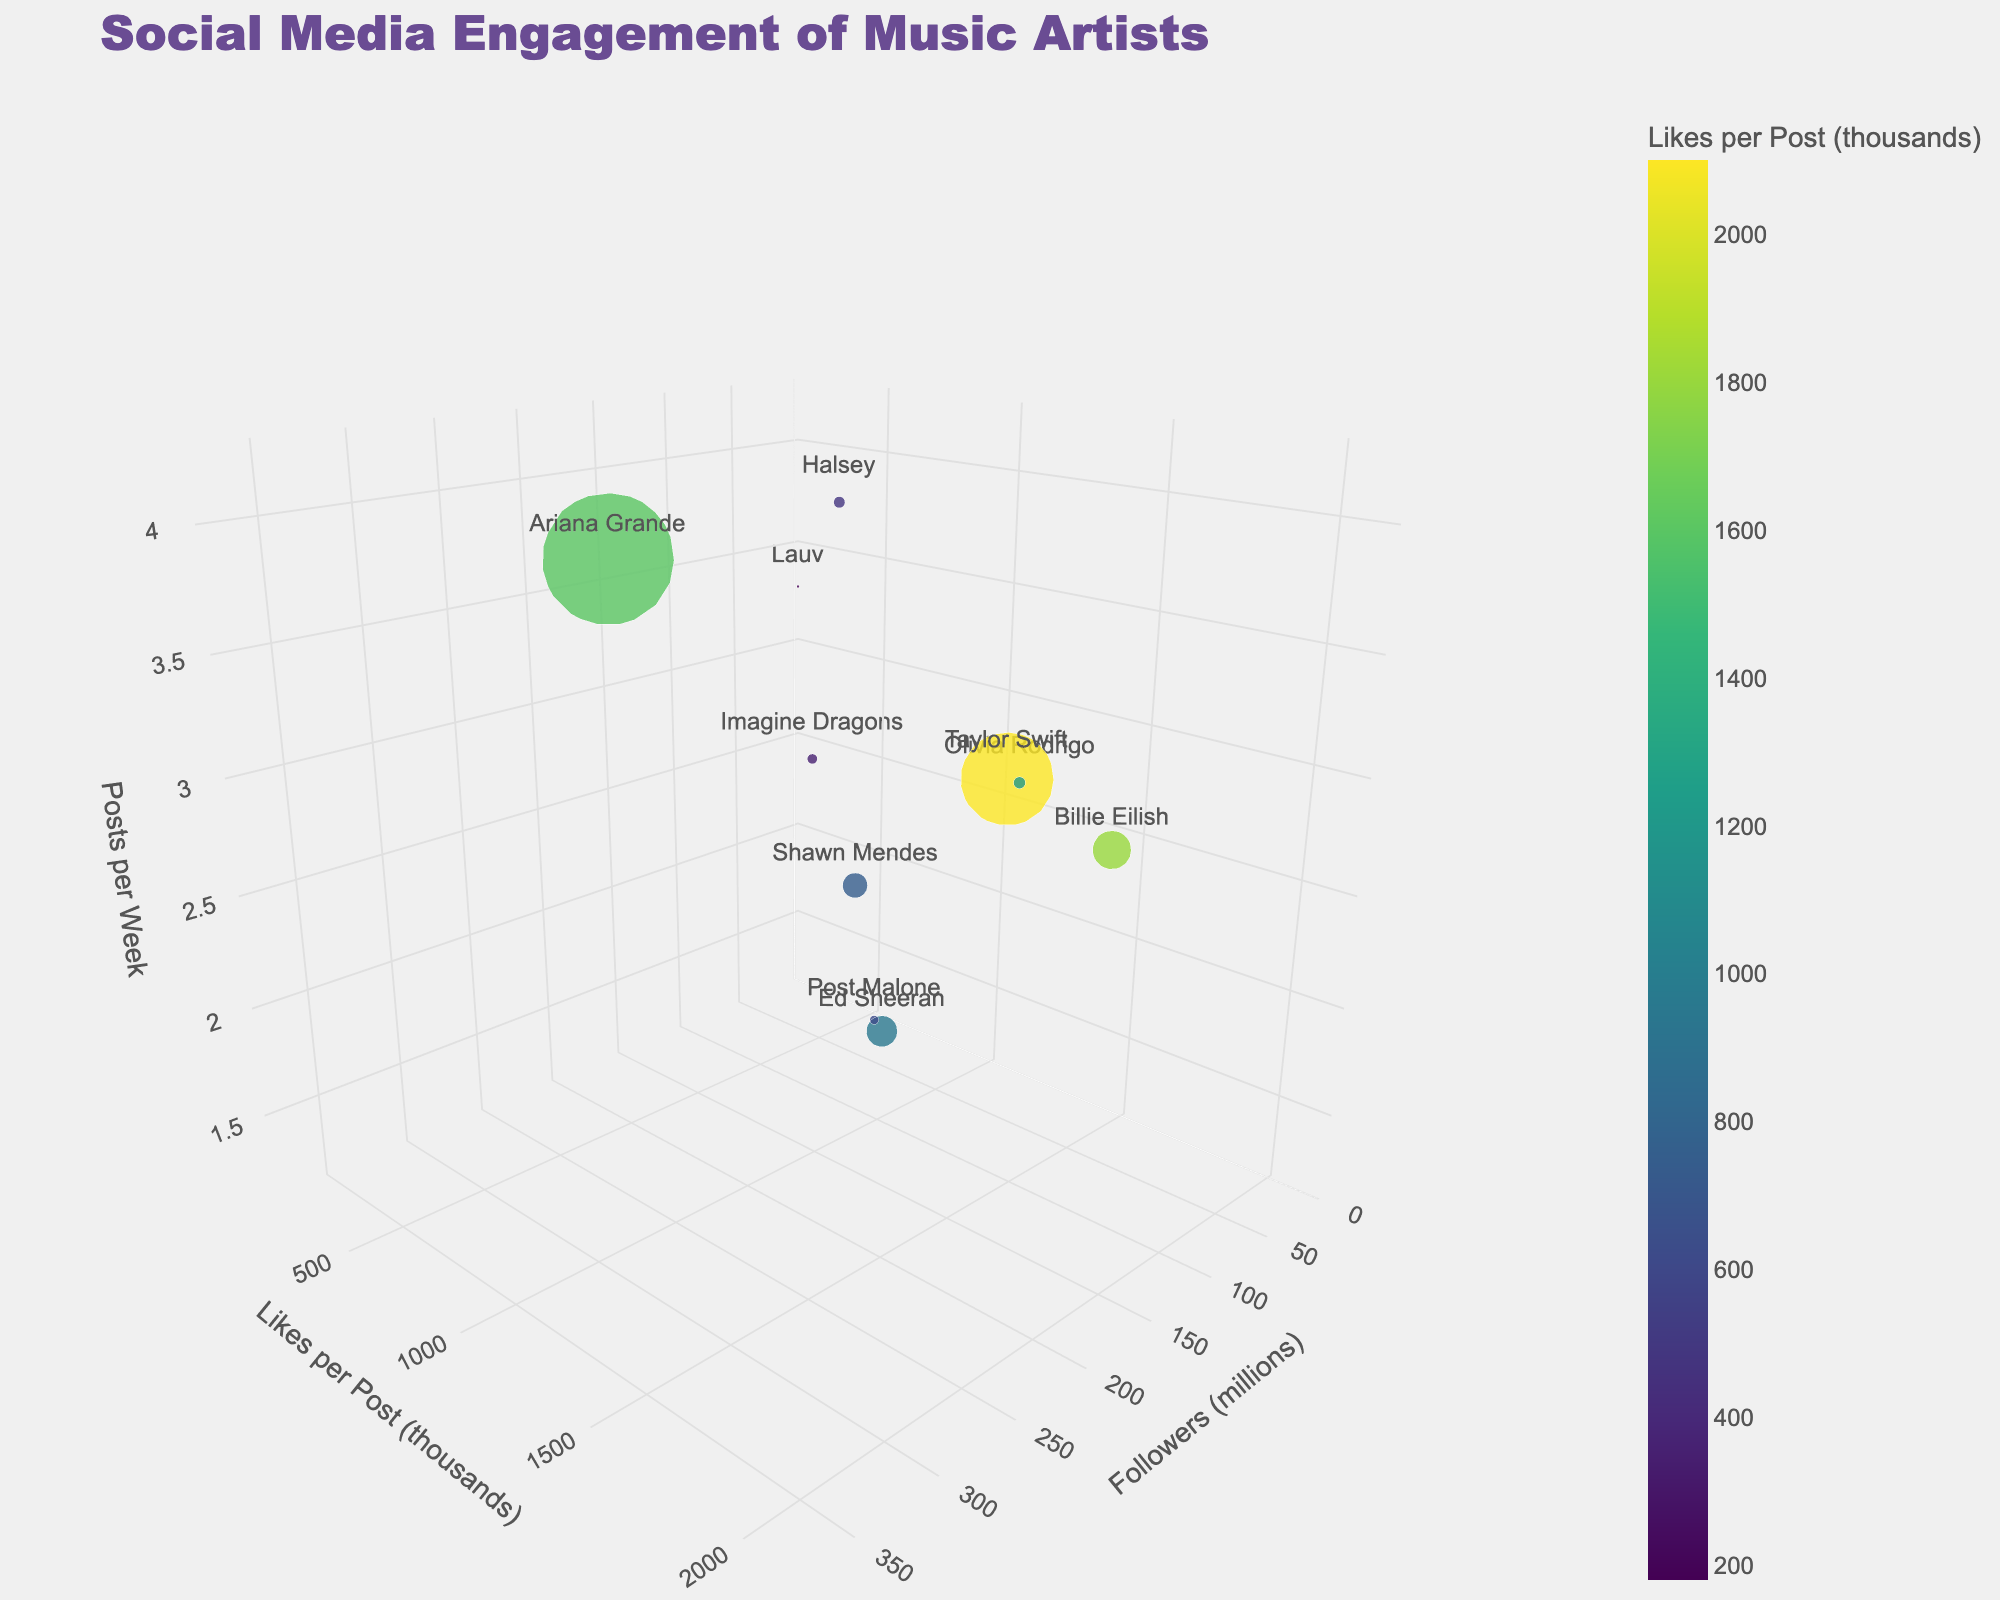Which artist has the most followers? Look for the artist with the highest value on the x-axis, which represents followers in millions. Taylor Swift has the highest value at 261 million followers.
Answer: Taylor Swift Which artist has the highest likes per post? Look for the artist with the highest value on the y-axis, which represents likes per post in thousands. Taylor Swift has the highest value at 2100 thousand likes per post.
Answer: Taylor Swift Which artist posts the most frequently per week? Look for the artist with the highest value on the z-axis, which represents posts per week. Ariana Grande posts the most frequently at 4.2 posts per week.
Answer: Ariana Grande How many artists have more than 100 million followers? Count the number of artists with a value greater than 100 million on the x-axis. Taylor Swift, Billie Eilish, and Ariana Grande each have more than 100 million followers.
Answer: 3 Who has more likes per post, Billie Eilish or Ariana Grande? Compare the y-axis values for Billie Eilish and Ariana Grande. Billie Eilish has 1800 thousand likes per post, and Ariana Grande has 1600 thousand likes per post.
Answer: Billie Eilish Which artist posts the least per week and how many posts per week? Look for the artist with the lowest value on the z-axis. Post Malone posts the least with 1.2 posts per week.
Answer: Post Malone, 1.2 Which artist with more than 50 million followers has the lowest likes per post? Identify artists with more than 50 million followers on the x-axis, then find the one with the lowest y-axis value. Ed Sheeran has 87 million followers and 950 thousand likes per post, which is the lowest among artists with more than 50 million followers.
Answer: Ed Sheeran How does Olivia Rodrigo's engagement compare to Halsey's in terms of post frequency? Compare the z-axis values for Olivia Rodrigo and Halsey. Olivia Rodrigo posts 2.7 times per week, while Halsey posts 3.8 times per week.
Answer: Halsey posts more frequently than Olivia Rodrigo What is the average number of followers for artists who have more than 1000 likes per post? Identify the artists with likes per post greater than 1000 on the y-axis (Taylor Swift, Billie Eilish, Ariana Grande, and Olivia Rodrigo), then calculate their average number of followers. Sum of followers = 261 + 108 + 370 + 33 = 772 million. Average = 772 / 4 = 193 million.
Answer: 193 million Which artist has a similar number of followers and likes per post? Look for an artist whose x-axis (followers) and y-axis (likes per post) values are close to each other. Billie Eilish has 108 million followers and 1800 thousand likes per post, indicating a balanced engagement.
Answer: Billie Eilish 